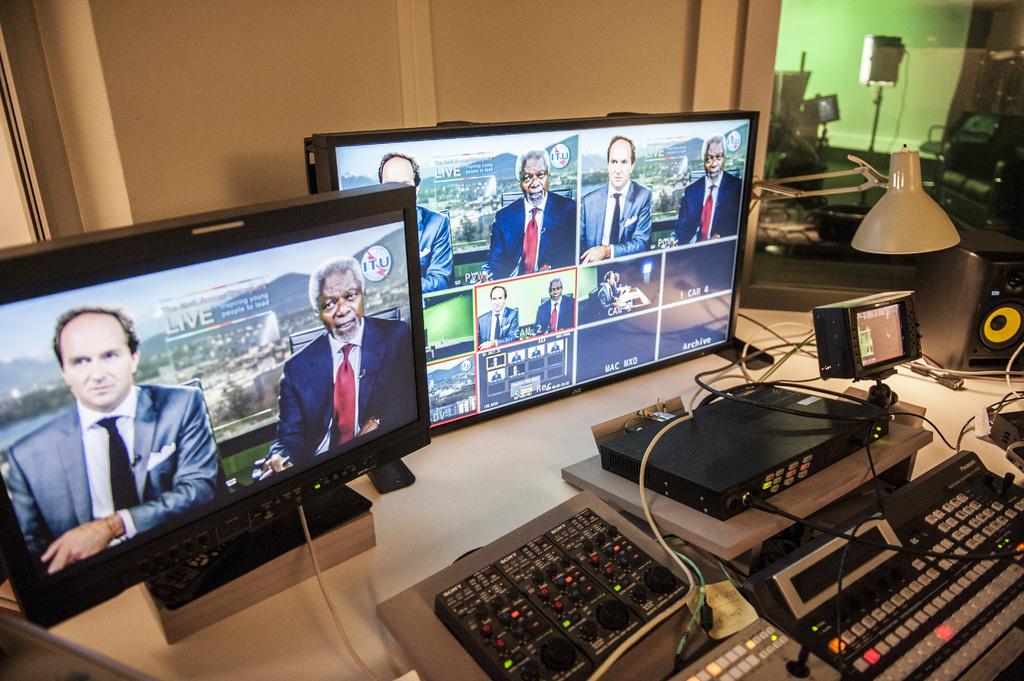Is the program being shown live?
Offer a terse response. Yes. Is that news?
Your response must be concise. Yes. 